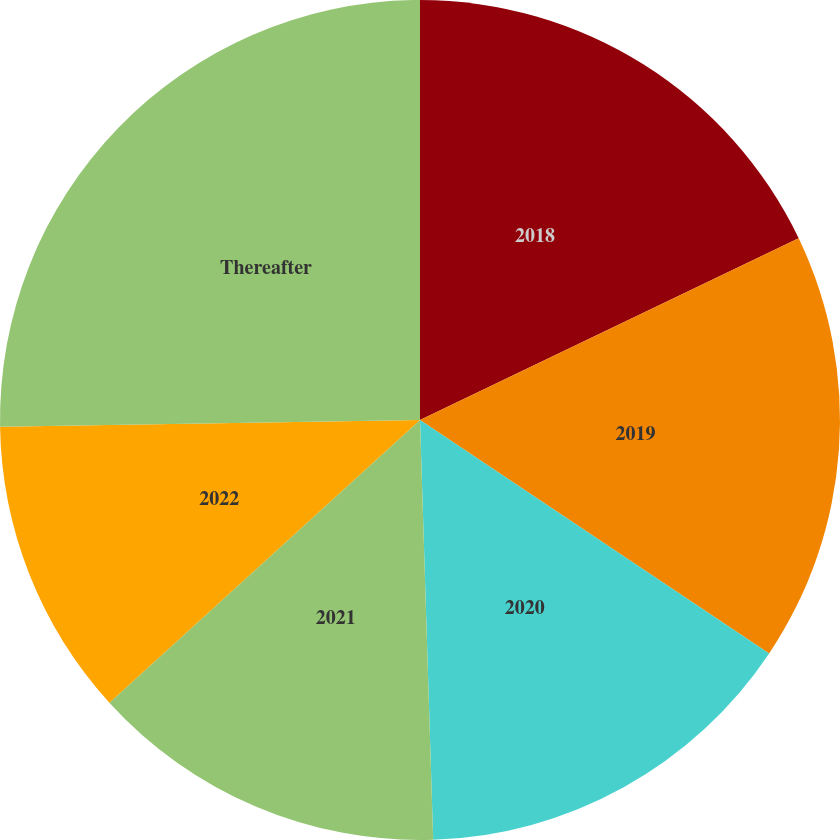<chart> <loc_0><loc_0><loc_500><loc_500><pie_chart><fcel>2018<fcel>2019<fcel>2020<fcel>2021<fcel>2022<fcel>Thereafter<nl><fcel>17.88%<fcel>16.5%<fcel>15.12%<fcel>13.75%<fcel>11.49%<fcel>25.26%<nl></chart> 